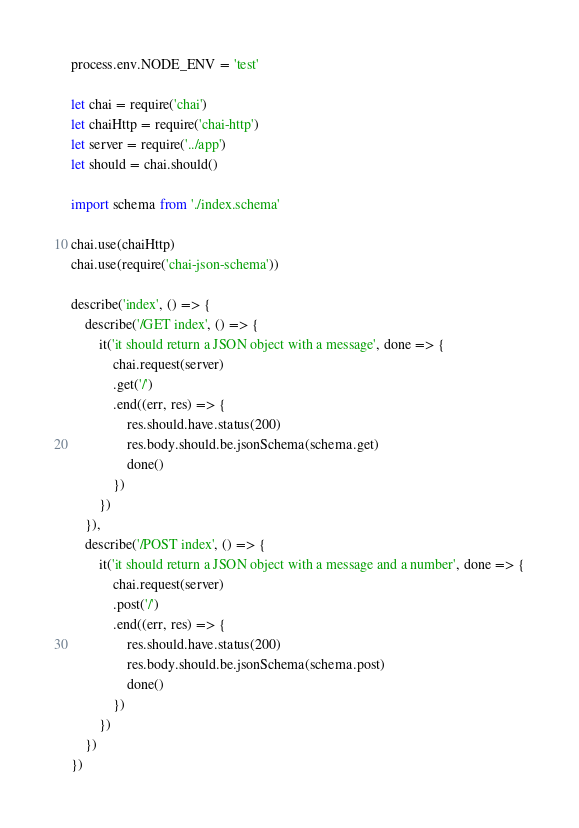<code> <loc_0><loc_0><loc_500><loc_500><_TypeScript_>process.env.NODE_ENV = 'test'

let chai = require('chai')
let chaiHttp = require('chai-http')
let server = require('../app')
let should = chai.should()

import schema from './index.schema'

chai.use(chaiHttp)
chai.use(require('chai-json-schema'))

describe('index', () => {
    describe('/GET index', () => {
        it('it should return a JSON object with a message', done => {
            chai.request(server)
            .get('/')
            .end((err, res) => {
                res.should.have.status(200)
                res.body.should.be.jsonSchema(schema.get)
                done()
            })
        })
    }),
    describe('/POST index', () => {
        it('it should return a JSON object with a message and a number', done => {
            chai.request(server)
            .post('/')
            .end((err, res) => {
                res.should.have.status(200)
                res.body.should.be.jsonSchema(schema.post)
                done()
            })
        })
    })
})</code> 